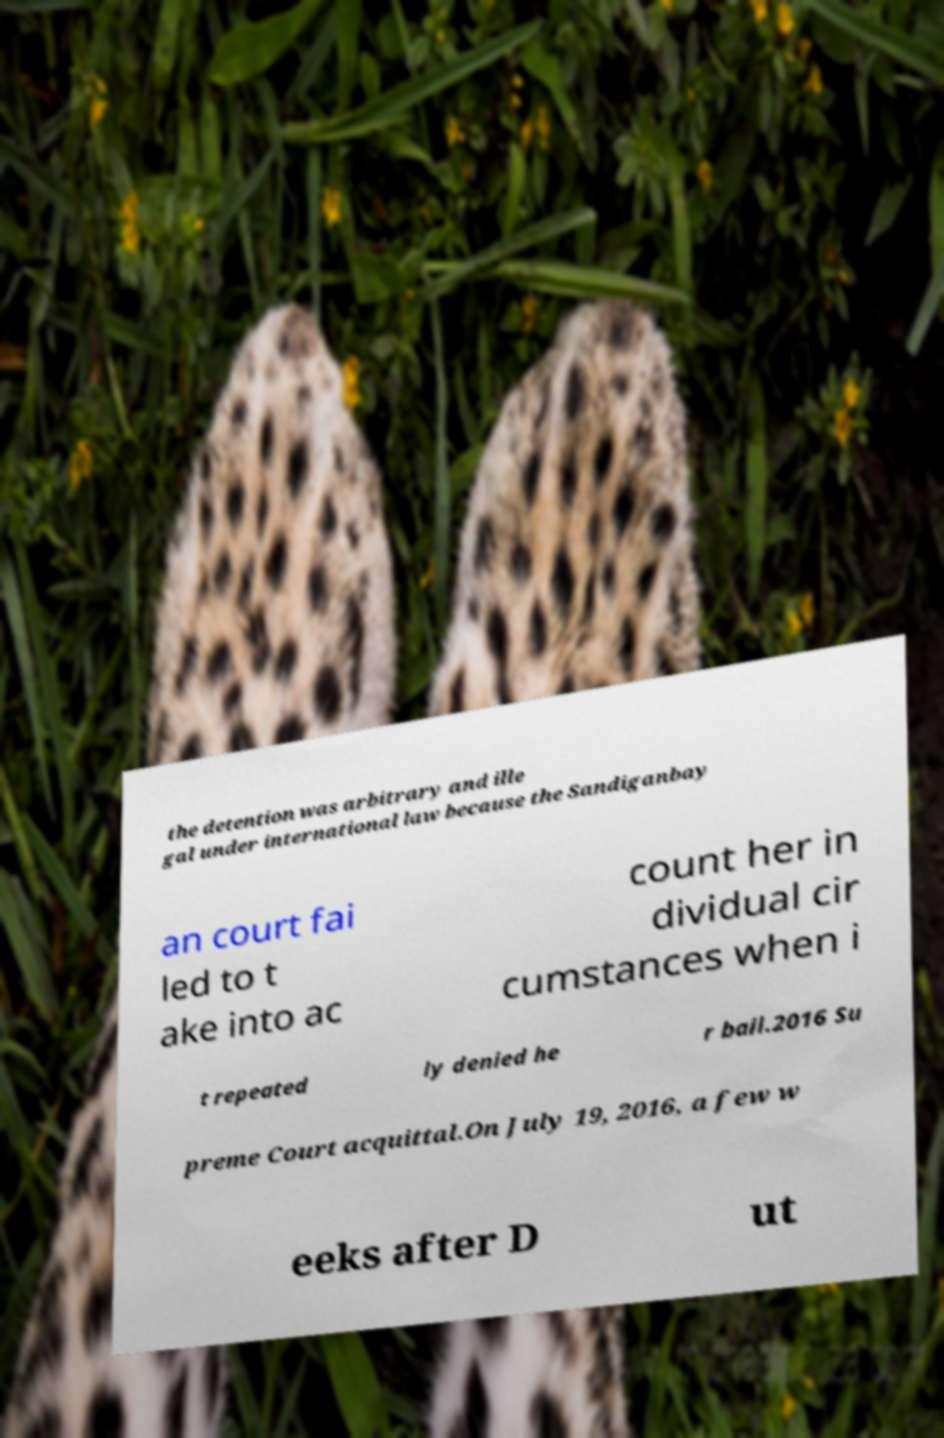Please read and relay the text visible in this image. What does it say? the detention was arbitrary and ille gal under international law because the Sandiganbay an court fai led to t ake into ac count her in dividual cir cumstances when i t repeated ly denied he r bail.2016 Su preme Court acquittal.On July 19, 2016, a few w eeks after D ut 